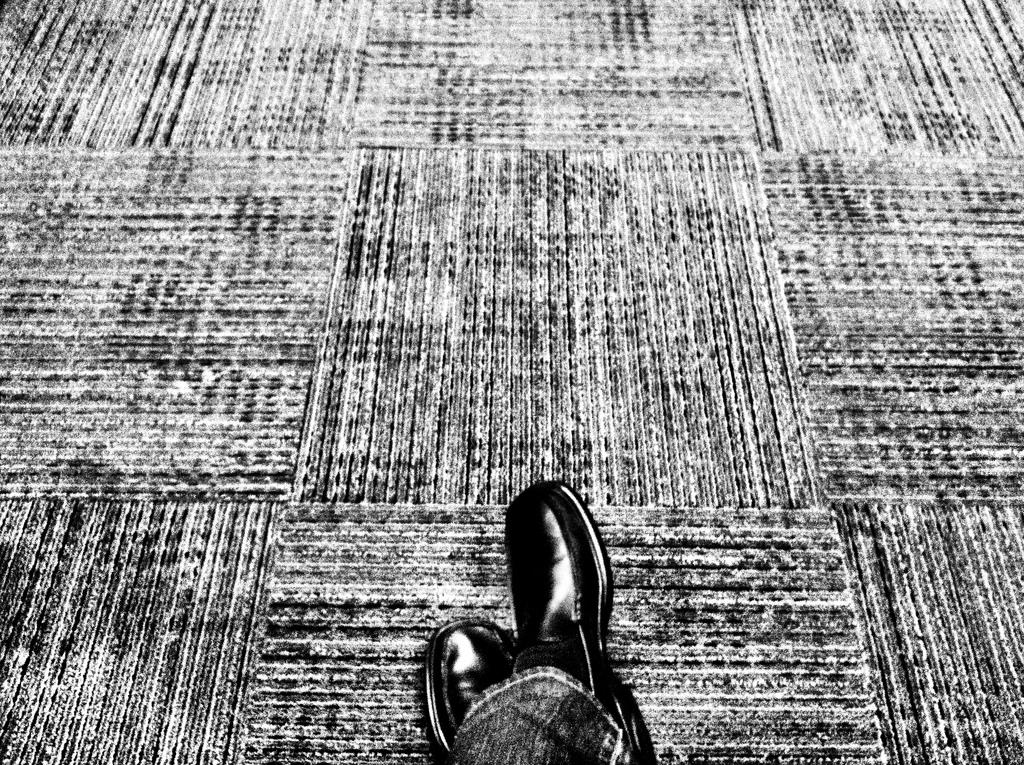What part of a person can be seen in the image? There are legs of a person visible in the image. Where are the legs located in relation to the floor? The legs are on the floor. How many dogs are walking with the person in the image? There are no dogs present in the image, and the person's legs are stationary on the floor. What type of doll is sitting on the person's lap in the image? There is no doll present in the image; only the person's legs are visible. 